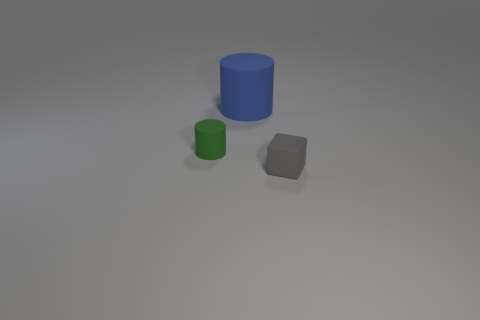Add 1 cylinders. How many objects exist? 4 Subtract all cylinders. How many objects are left? 1 Subtract all brown metal cylinders. Subtract all gray blocks. How many objects are left? 2 Add 1 small matte objects. How many small matte objects are left? 3 Add 2 small gray matte objects. How many small gray matte objects exist? 3 Subtract 0 green cubes. How many objects are left? 3 